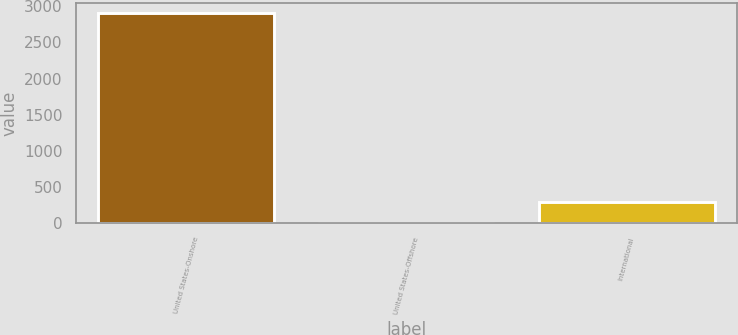Convert chart to OTSL. <chart><loc_0><loc_0><loc_500><loc_500><bar_chart><fcel>United States-Onshore<fcel>United States-Offshore<fcel>International<nl><fcel>2904.2<fcel>5.1<fcel>295.01<nl></chart> 